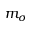<formula> <loc_0><loc_0><loc_500><loc_500>m _ { \sigma }</formula> 